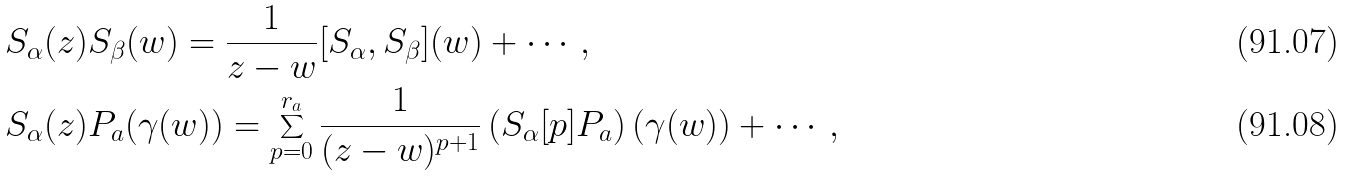Convert formula to latex. <formula><loc_0><loc_0><loc_500><loc_500>& S _ { \alpha } ( z ) S _ { \beta } ( w ) = \frac { 1 } { z - w } [ S _ { \alpha } , S _ { \beta } ] ( w ) + \cdots , \\ & S _ { \alpha } ( z ) P _ { a } ( \gamma ( w ) ) = \sum _ { p = 0 } ^ { r _ { a } } \frac { 1 } { ( z - w ) ^ { p + 1 } } \left ( S _ { \alpha } [ p ] P _ { a } \right ) ( \gamma ( w ) ) + \cdots ,</formula> 